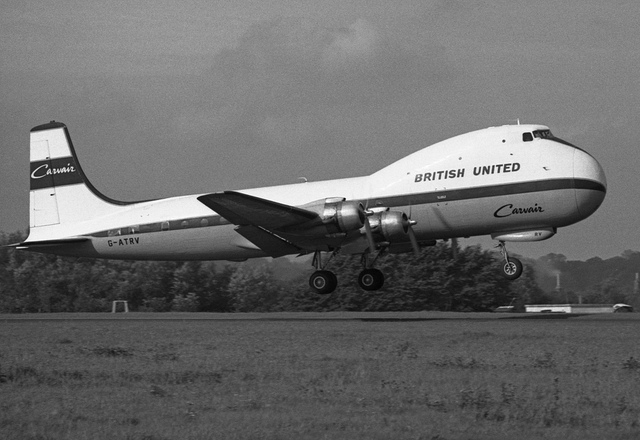Read and extract the text from this image. Britis UNITED Carvair Carvair ATRY G 